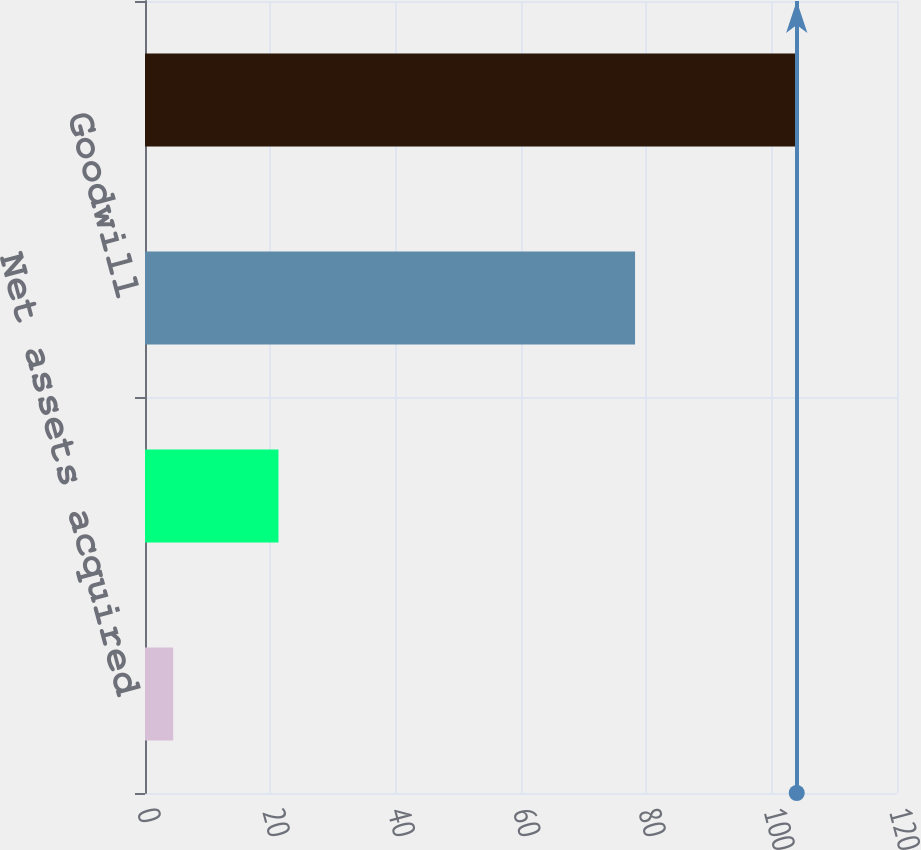<chart> <loc_0><loc_0><loc_500><loc_500><bar_chart><fcel>Net assets acquired<fcel>Intangible assets acquired<fcel>Goodwill<fcel>Total<nl><fcel>4.5<fcel>21.3<fcel>78.2<fcel>104<nl></chart> 